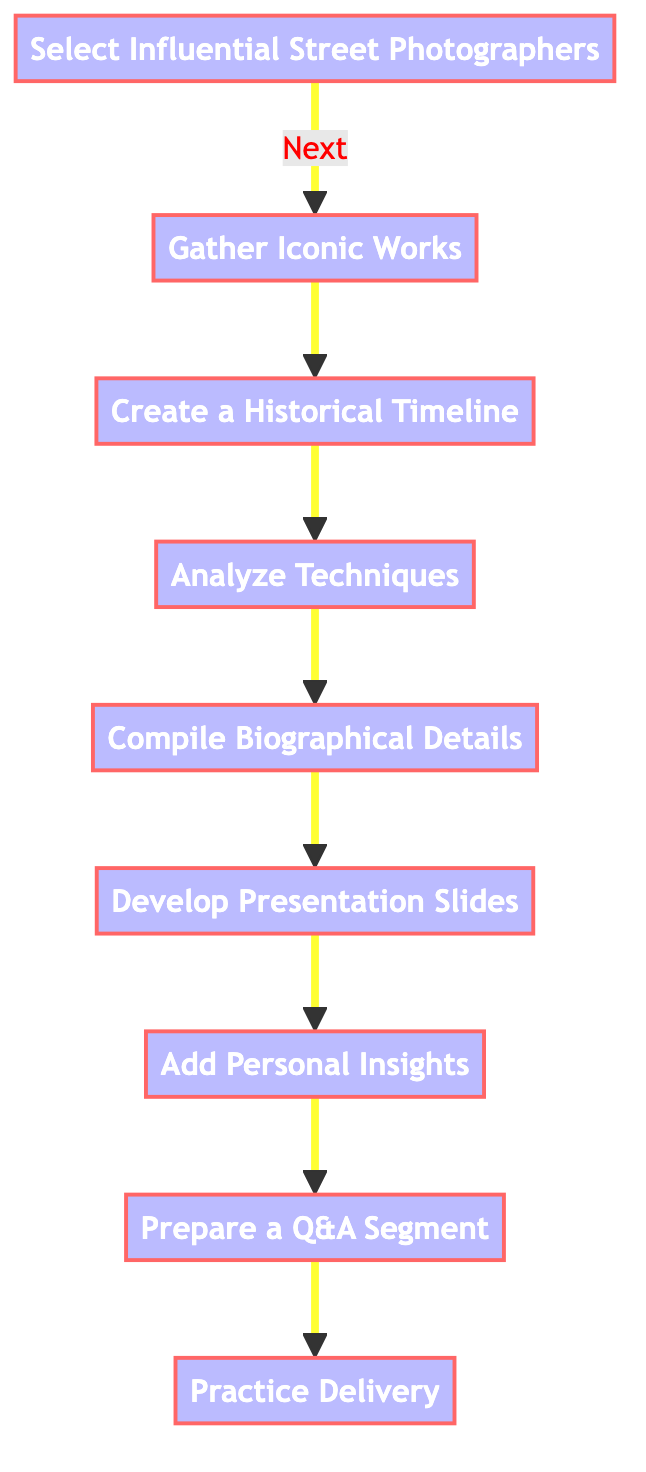What is the first step in creating a photography presentation? The first step, as shown in the diagram, is "Select Influential Street Photographers." This is the starting node that initiates the flow of the process outlined in the diagram.
Answer: Select Influential Street Photographers How many nodes are present in the diagram? By counting all the instructions listed in the diagram, there are a total of nine nodes, each representing a distinct step in the process.
Answer: Nine What is the last step of the process? The last step indicated in the diagram is "Practice Delivery," which is the final node after all preceding steps have been completed.
Answer: Practice Delivery Which two steps are directly connected? The steps "Gather Iconic Works" and "Create a Historical Timeline" are directly connected, as "Gather Iconic Works" leads directly to "Create a Historical Timeline."
Answer: Gather Iconic Works and Create a Historical Timeline How many steps involve analysis? There are two steps that involve analysis: "Analyze Techniques" and "Compile Biographical Details." These steps require careful examination of the photographers' works and backgrounds.
Answer: Two What is the relationship between "Add Personal Insights" and "Prepare a Q&A Segment"? "Add Personal Insights" is a prerequisite to "Prepare a Q&A Segment," indicating that personal reflections should be included before engaging with the audience for questions.
Answer: Prerequisite What should one focus on while developing presentation slides? While developing presentation slides, one should focus on creating engaging slides with a mix of text and visuals, particularly high-resolution images of the photographers' works.
Answer: High-resolution images Which step emphasizes audience engagement? The step that emphasizes audience engagement is "Prepare a Q&A Segment," as it specifically involves planning for audience interaction after the presentation.
Answer: Prepare a Q&A Segment How does one ensure smooth delivery of the presentation? One should "Practice Delivery" multiple times, focusing on clear articulation and pacing, to ensure that the presentation is delivered smoothly.
Answer: Practice Delivery 